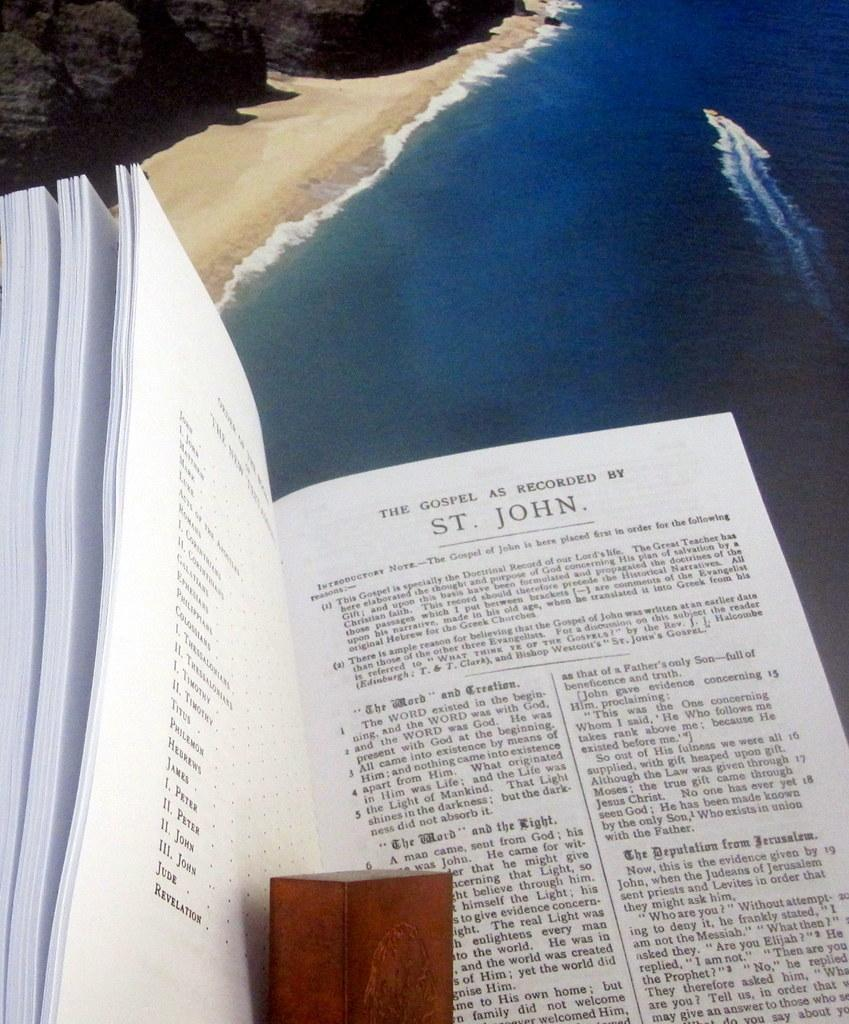<image>
Write a terse but informative summary of the picture. A bible open to a page that reads The Gospel as Recorded by St. John. 